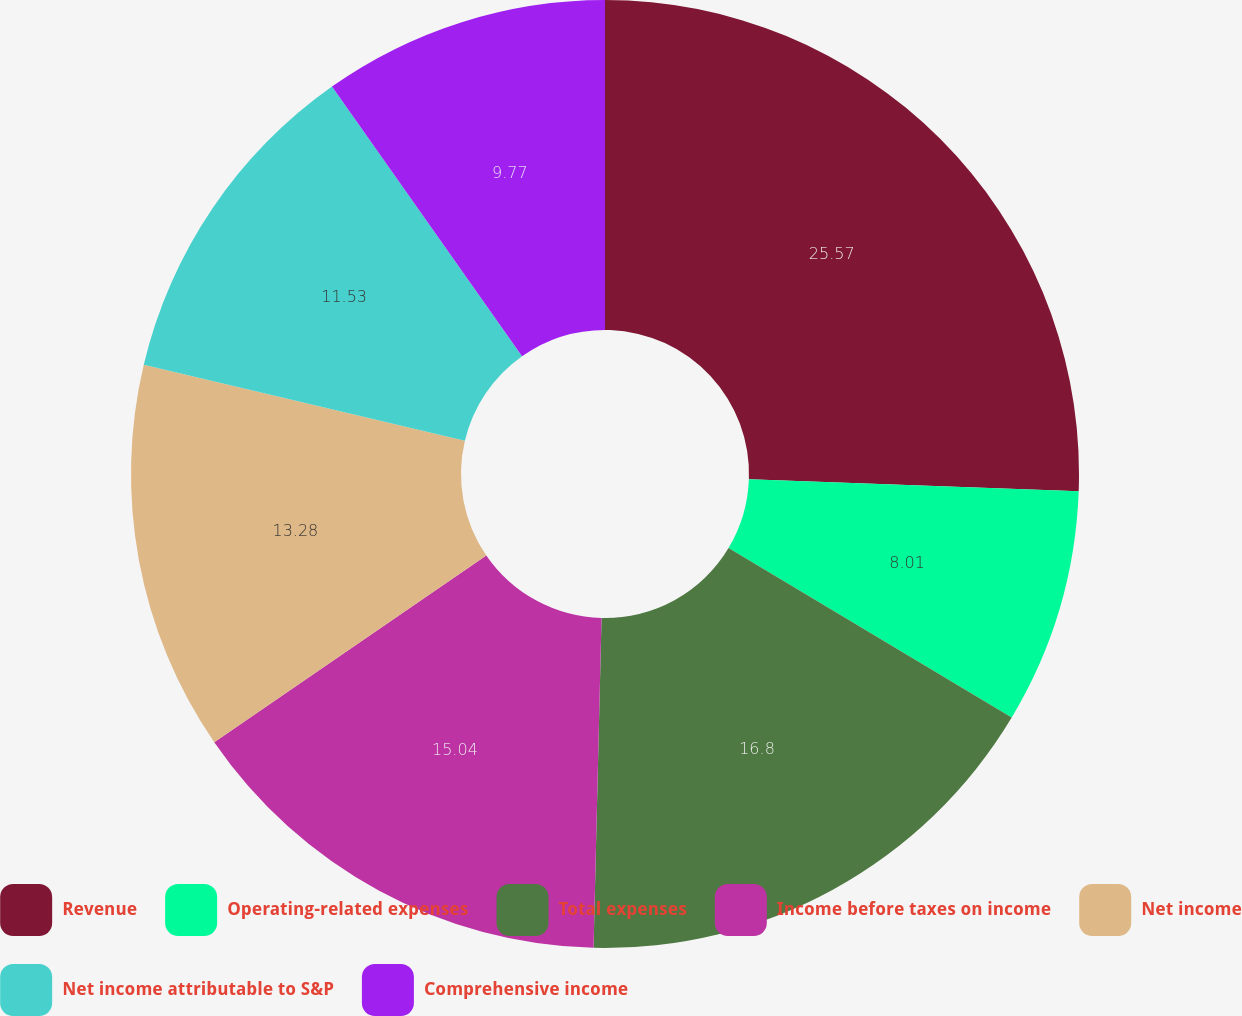Convert chart to OTSL. <chart><loc_0><loc_0><loc_500><loc_500><pie_chart><fcel>Revenue<fcel>Operating-related expenses<fcel>Total expenses<fcel>Income before taxes on income<fcel>Net income<fcel>Net income attributable to S&P<fcel>Comprehensive income<nl><fcel>25.58%<fcel>8.01%<fcel>16.8%<fcel>15.04%<fcel>13.28%<fcel>11.53%<fcel>9.77%<nl></chart> 